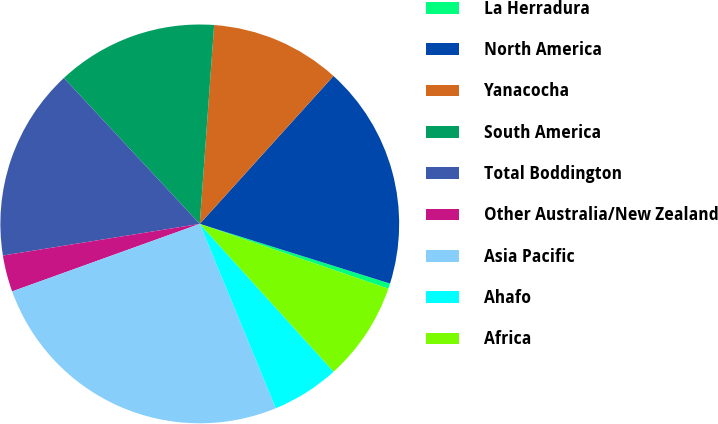<chart> <loc_0><loc_0><loc_500><loc_500><pie_chart><fcel>La Herradura<fcel>North America<fcel>Yanacocha<fcel>South America<fcel>Total Boddington<fcel>Other Australia/New Zealand<fcel>Asia Pacific<fcel>Ahafo<fcel>Africa<nl><fcel>0.43%<fcel>18.14%<fcel>10.55%<fcel>13.08%<fcel>15.61%<fcel>2.96%<fcel>25.73%<fcel>5.49%<fcel>8.02%<nl></chart> 